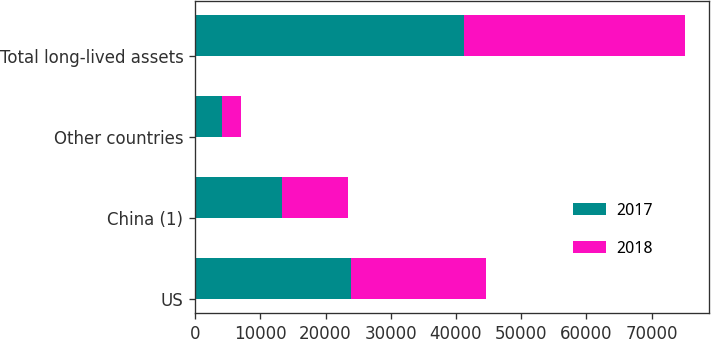Convert chart. <chart><loc_0><loc_0><loc_500><loc_500><stacked_bar_chart><ecel><fcel>US<fcel>China (1)<fcel>Other countries<fcel>Total long-lived assets<nl><fcel>2017<fcel>23963<fcel>13268<fcel>4073<fcel>41304<nl><fcel>2018<fcel>20637<fcel>10211<fcel>2935<fcel>33783<nl></chart> 